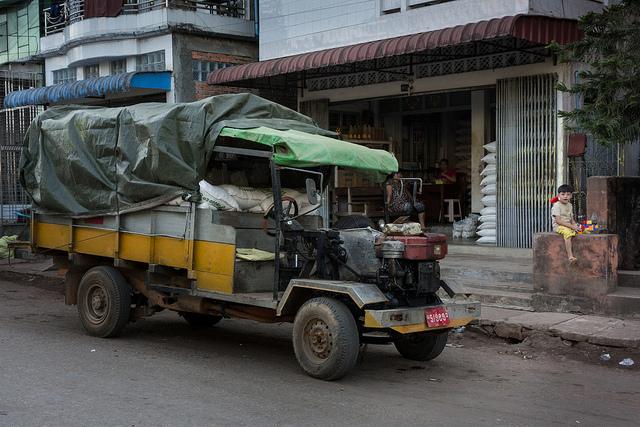What color is the tarp covering the truck?
Write a very short answer. Green. What is the dominant shade of color on the truck?
Short answer required. Green. What color is the wagon?
Give a very brief answer. Yellow. Does this truck sell food items?
Write a very short answer. No. Does the vehicle have an American flag?
Give a very brief answer. No. Is this taken in the US?
Concise answer only. No. Is this a new model vehicle?
Keep it brief. No. 